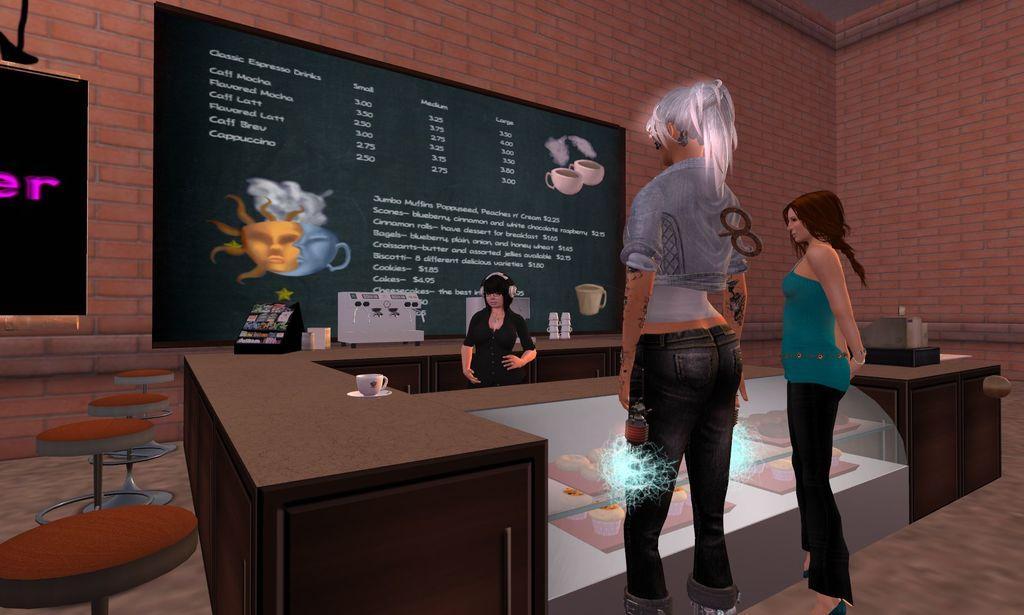In one or two sentences, can you explain what this image depicts? In this image we can see the animated picture of three women standing on the ground. One woman is wearing headphones. In the foreground we can see some food items placed in racks. To the left side of the image we can see a cup placed on the table, a group of chairs placed on the ground. In the background, we can see a signboard with some text, some objects placed in racks, machines and cups placed on the counter top and the wall. 